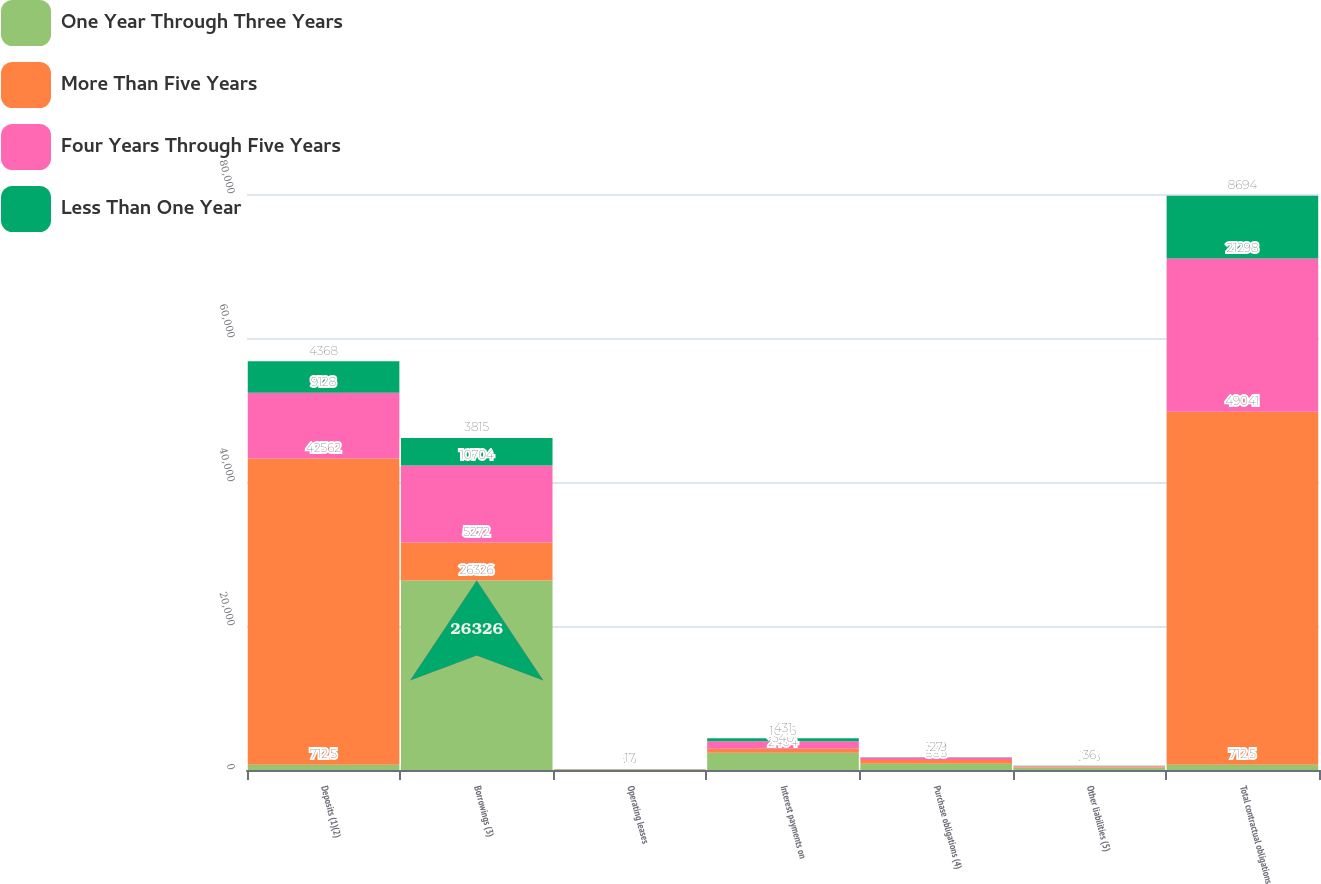<chart> <loc_0><loc_0><loc_500><loc_500><stacked_bar_chart><ecel><fcel>Deposits (1)(2)<fcel>Borrowings (3)<fcel>Operating leases<fcel>Interest payments on<fcel>Purchase obligations (4)<fcel>Other liabilities (5)<fcel>Total contractual obligations<nl><fcel>One Year Through Three Years<fcel>712.5<fcel>26326<fcel>94<fcel>2404<fcel>885<fcel>348<fcel>712.5<nl><fcel>More Than Five Years<fcel>42562<fcel>5272<fcel>13<fcel>540<fcel>507<fcel>147<fcel>49041<nl><fcel>Four Years Through Five Years<fcel>9128<fcel>10704<fcel>23<fcel>1046<fcel>349<fcel>48<fcel>21298<nl><fcel>Less Than One Year<fcel>4368<fcel>3815<fcel>17<fcel>431<fcel>27<fcel>36<fcel>8694<nl></chart> 